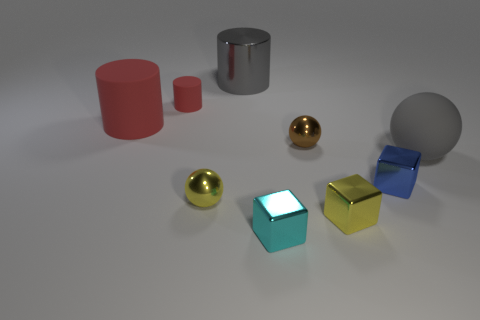Can you describe the material textures visible in the image? Certainly! The image features objects with two distinct textures: some have a shiny, reflective quality, such as the spheres and the rightmost cylinder, indicating a smooth and possibly metallic surface; others are matte, diffusing light evenly across their surfaces, like the cubes and the left cylinder, which might suggest a more plastic or painted finish. 